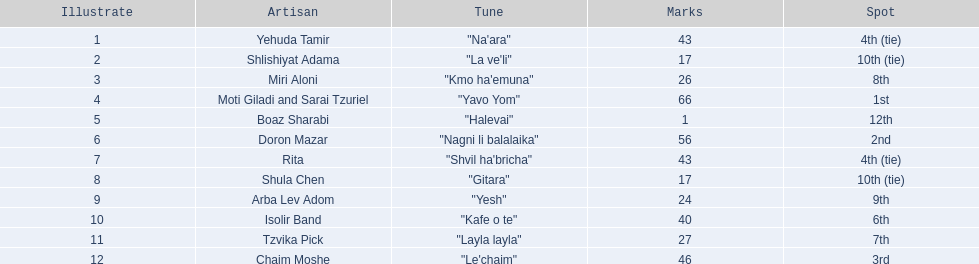Who were all the artists at the contest? Yehuda Tamir, Shlishiyat Adama, Miri Aloni, Moti Giladi and Sarai Tzuriel, Boaz Sharabi, Doron Mazar, Rita, Shula Chen, Arba Lev Adom, Isolir Band, Tzvika Pick, Chaim Moshe. Parse the full table in json format. {'header': ['Illustrate', 'Artisan', 'Tune', 'Marks', 'Spot'], 'rows': [['1', 'Yehuda Tamir', '"Na\'ara"', '43', '4th (tie)'], ['2', 'Shlishiyat Adama', '"La ve\'li"', '17', '10th (tie)'], ['3', 'Miri Aloni', '"Kmo ha\'emuna"', '26', '8th'], ['4', 'Moti Giladi and Sarai Tzuriel', '"Yavo Yom"', '66', '1st'], ['5', 'Boaz Sharabi', '"Halevai"', '1', '12th'], ['6', 'Doron Mazar', '"Nagni li balalaika"', '56', '2nd'], ['7', 'Rita', '"Shvil ha\'bricha"', '43', '4th (tie)'], ['8', 'Shula Chen', '"Gitara"', '17', '10th (tie)'], ['9', 'Arba Lev Adom', '"Yesh"', '24', '9th'], ['10', 'Isolir Band', '"Kafe o te"', '40', '6th'], ['11', 'Tzvika Pick', '"Layla layla"', '27', '7th'], ['12', 'Chaim Moshe', '"Le\'chaim"', '46', '3rd']]} What were their point totals? 43, 17, 26, 66, 1, 56, 43, 17, 24, 40, 27, 46. Of these, which is the least amount of points? 1. Which artists received this point total? Boaz Sharabi. 